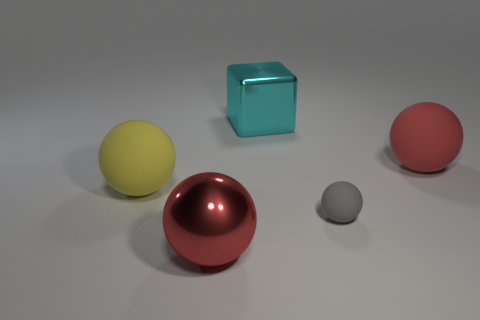Subtract all gray rubber spheres. How many spheres are left? 3 Subtract all yellow balls. How many balls are left? 3 Subtract all purple balls. Subtract all green blocks. How many balls are left? 4 Add 2 yellow things. How many objects exist? 7 Subtract all blocks. How many objects are left? 4 Add 2 spheres. How many spheres exist? 6 Subtract 1 gray balls. How many objects are left? 4 Subtract all big red things. Subtract all tiny rubber balls. How many objects are left? 2 Add 4 cyan metal objects. How many cyan metal objects are left? 5 